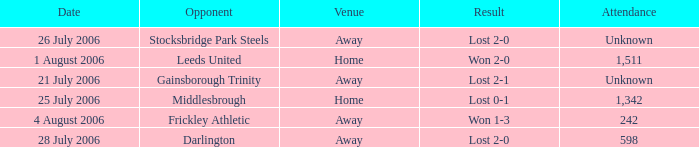What is the result from the Leeds United opponent? Won 2-0. 